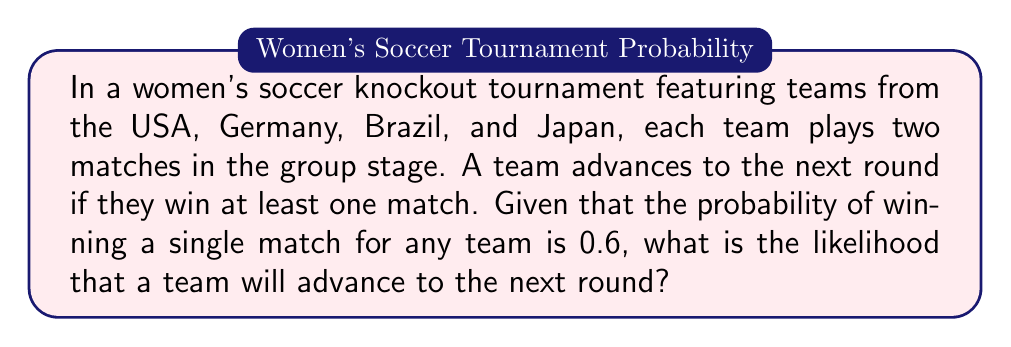Show me your answer to this math problem. Let's approach this step-by-step:

1) First, we need to identify what we're calculating. We want the probability of a team winning at least one match out of two.

2) It's often easier to calculate the probability of the complement event (not advancing) and then subtract from 1. So, we'll calculate the probability of losing both matches and then subtract from 1.

3) The probability of losing a single match is $1 - 0.6 = 0.4$.

4) For a team to not advance, they need to lose both matches. Since the matches are independent events, we multiply the probabilities:

   $P(\text{not advancing}) = 0.4 \times 0.4 = 0.16$

5) Therefore, the probability of advancing is:

   $P(\text{advancing}) = 1 - P(\text{not advancing}) = 1 - 0.16 = 0.84$

6) We can also calculate this directly:
   $P(\text{advancing}) = 1 - (1-0.6)^2 = 1 - 0.4^2 = 1 - 0.16 = 0.84$

This confirms our result.
Answer: The likelihood that a team will advance to the next round is $0.84$ or $84\%$. 